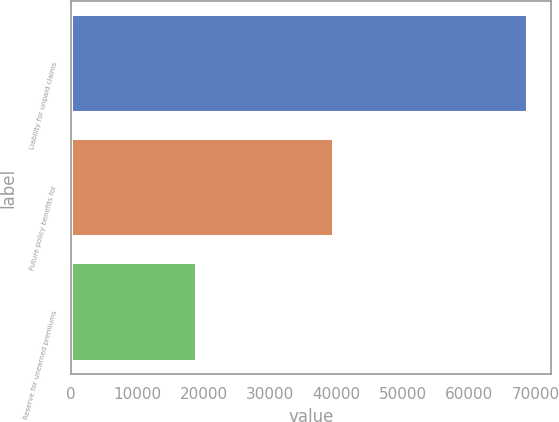Convert chart to OTSL. <chart><loc_0><loc_0><loc_500><loc_500><bar_chart><fcel>Liability for unpaid claims<fcel>Future policy benefits for<fcel>Reserve for unearned premiums<nl><fcel>68782<fcel>39591<fcel>18934<nl></chart> 